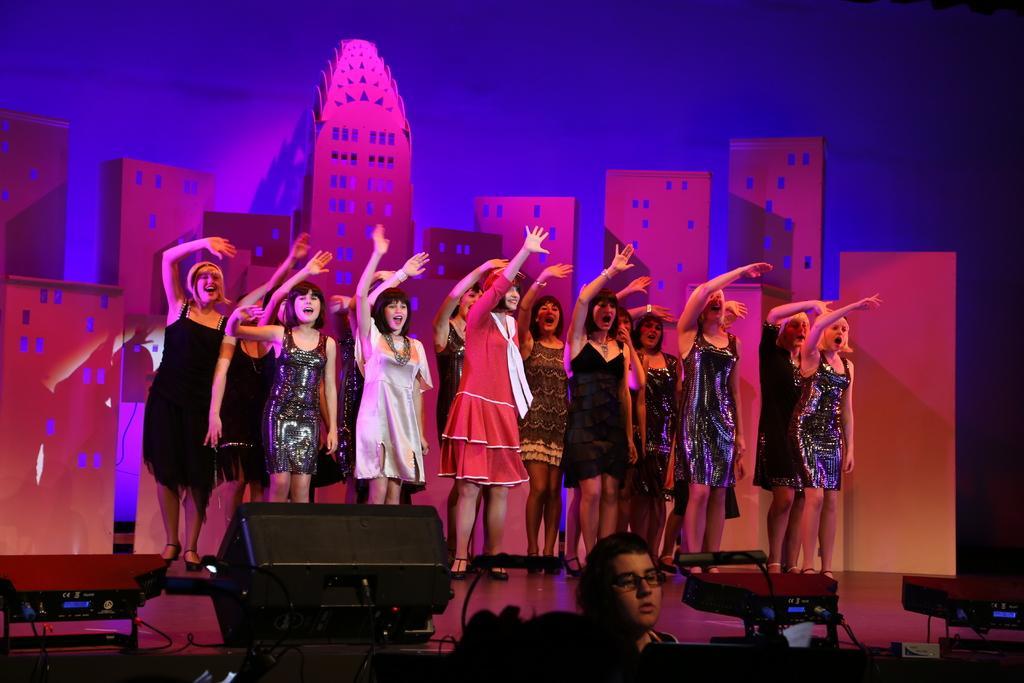Can you describe this image briefly? As we can see in the image there are group of people dancing and on floor there are disco lights. 